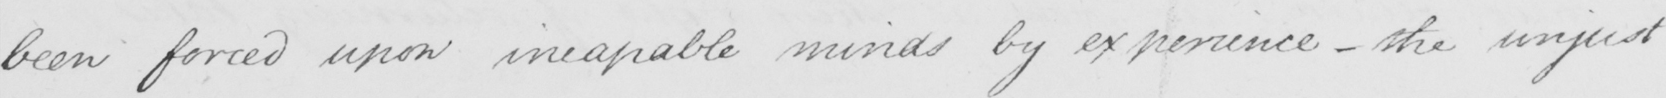Please provide the text content of this handwritten line. been forced upon incapable minds by experience  _  the unjust 